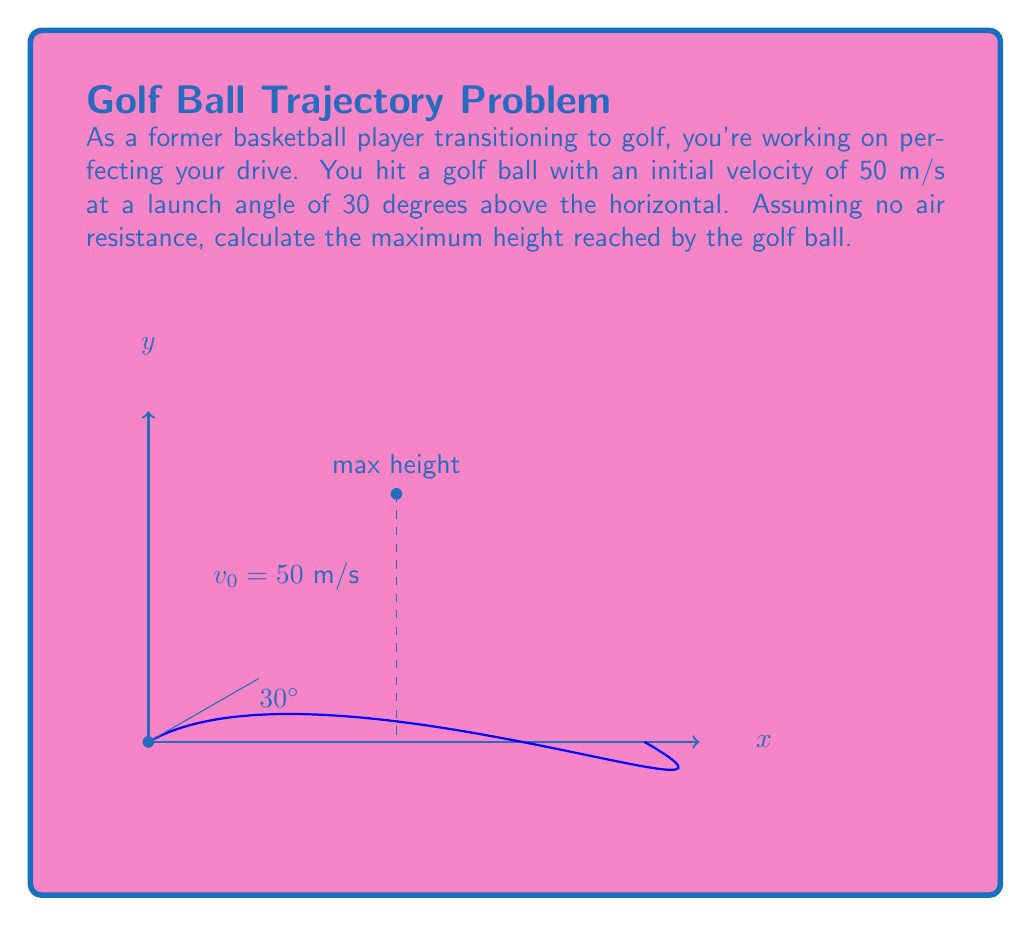Show me your answer to this math problem. Let's approach this step-by-step:

1) The maximum height is reached when the vertical velocity becomes zero. We can use the equations of motion for projectile motion to solve this problem.

2) The initial velocity components are:
   $v_{0x} = v_0 \cos \theta = 50 \cos 30° = 43.3$ m/s
   $v_{0y} = v_0 \sin \theta = 50 \sin 30° = 25$ m/s

3) The time to reach maximum height is when $v_y = 0$:
   $v_y = v_{0y} - gt$
   $0 = 25 - 9.8t$
   $t = \frac{25}{9.8} = 2.55$ seconds

4) Now we can use the equation for vertical displacement to find the maximum height:
   $y = v_{0y}t - \frac{1}{2}gt^2$
   
   $y = (25)(2.55) - \frac{1}{2}(9.8)(2.55)^2$
   
   $y = 63.75 - 31.875 = 31.875$ meters

5) Therefore, the maximum height reached by the golf ball is approximately 31.88 meters.
Answer: $31.88$ m 